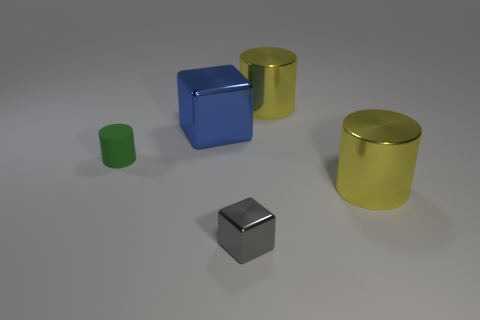Subtract all purple cubes. How many yellow cylinders are left? 2 Subtract all small green cylinders. How many cylinders are left? 2 Add 2 big metallic blocks. How many objects exist? 7 Subtract all cubes. How many objects are left? 3 Add 5 blue metal blocks. How many blue metal blocks exist? 6 Subtract 0 cyan blocks. How many objects are left? 5 Subtract all gray cylinders. Subtract all gray cubes. How many cylinders are left? 3 Subtract all matte objects. Subtract all small cubes. How many objects are left? 3 Add 4 matte cylinders. How many matte cylinders are left? 5 